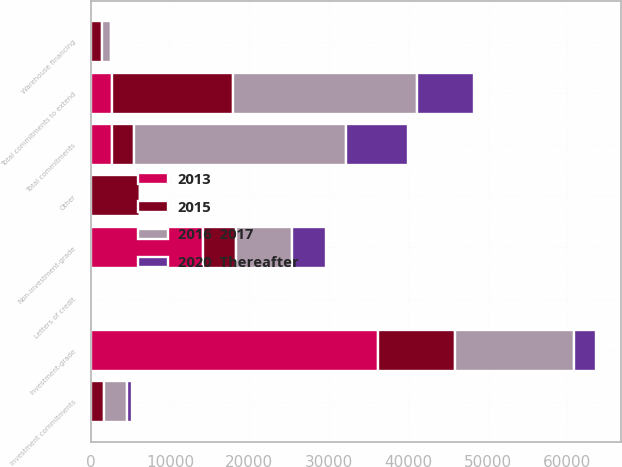Convert chart to OTSL. <chart><loc_0><loc_0><loc_500><loc_500><stacked_bar_chart><ecel><fcel>Investment-grade<fcel>Non-investment-grade<fcel>Warehouse financing<fcel>Total commitments to extend<fcel>Letters of credit<fcel>Investment commitments<fcel>Other<fcel>Total commitments<nl><fcel>2015<fcel>9712<fcel>4136<fcel>1306<fcel>15154<fcel>280<fcel>1684<fcel>6136<fcel>2719<nl><fcel>2016  2017<fcel>15003<fcel>7080<fcel>1152<fcel>23235<fcel>14<fcel>2818<fcel>87<fcel>26711<nl><fcel>2013<fcel>36200<fcel>14111<fcel>112<fcel>2719<fcel>10<fcel>25<fcel>42<fcel>2719<nl><fcel>2020  Thereafter<fcel>2719<fcel>4278<fcel>140<fcel>7137<fcel>4<fcel>637<fcel>56<fcel>7834<nl></chart> 